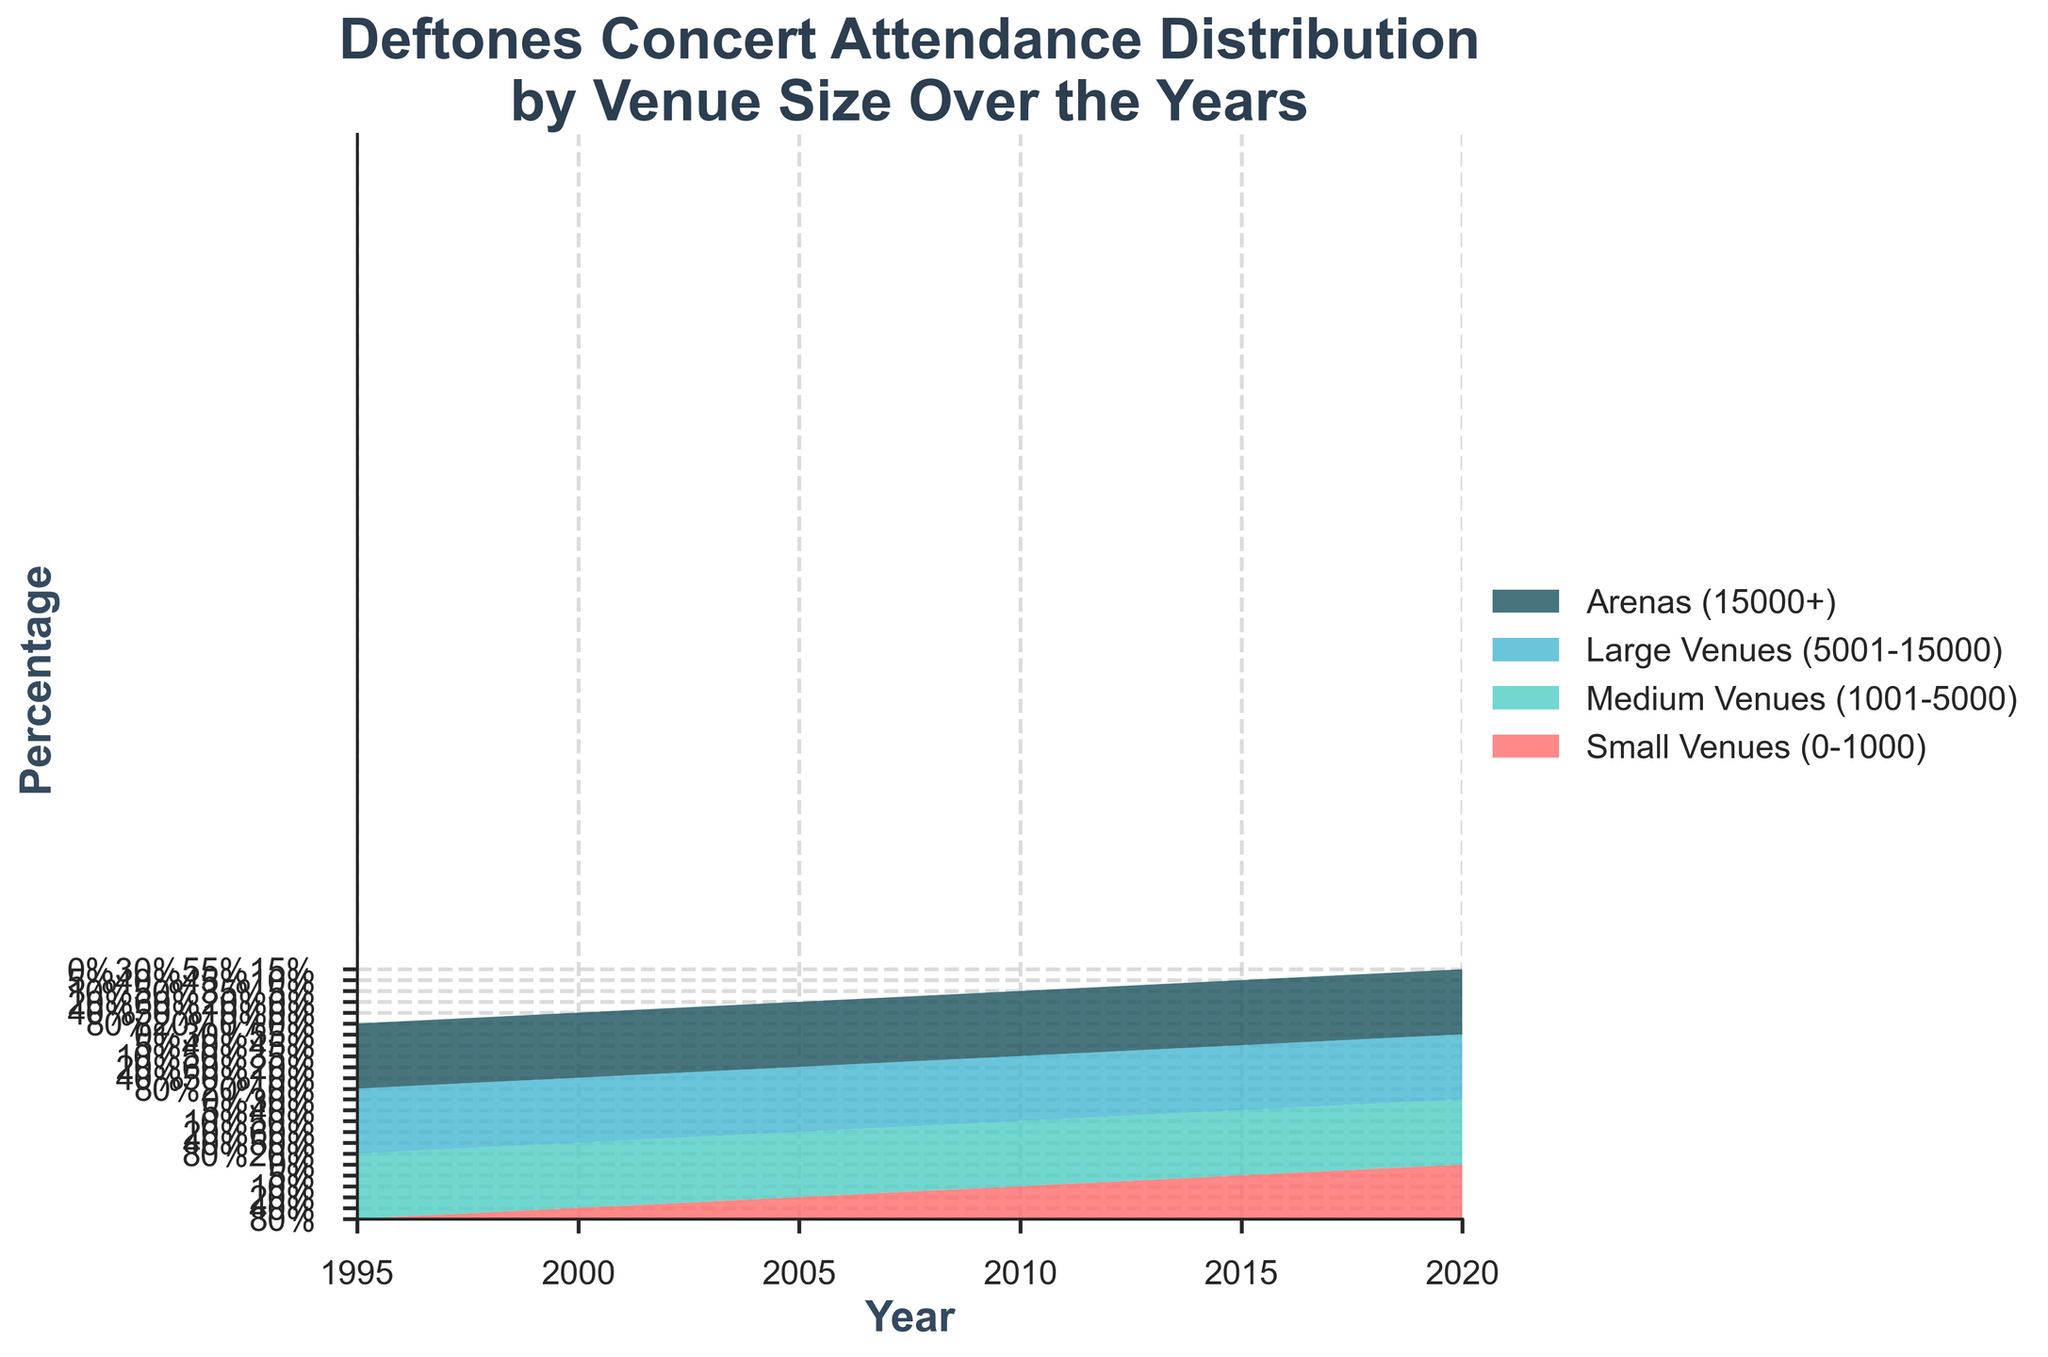what years are displayed on the x-axis? The x-axis of the graph displays the years when Deftones' concert attendance is documented. These years are read directly from the labels on the x-axis.
Answer: 1995, 2000, 2005, 2010, 2015, 2020 what is the title of the chart? The title of the chart provides an overview of the data shown and helps to understand what is being analyzed. It is read directly from the top of the chart.
Answer: Deftones Concert Attendance Distribution by Venue Size Over the Years which venue size had the highest percentage in 2015? To determine the highest percentage in 2015, look for the segment with the greatest height in that year on the chart. The colors and labels indicate the venue sizes.
Answer: Large Venues (5001-15000) how did the attendance at small venues (0-1000) change from 1995 to 2020? To understand the change in attendance at small venues from 1995 to 2020, compare the percentage values for small venues in both years.
Answer: Decreased from 80% to 0% in which year did medium venues (1001-5000) have their highest percentage? To find the year when medium venues had the highest percentage, look at the chart and identify the tallest segment specifically colored for medium venues.
Answer: 2005 what was the combined percentage of large venues (5001-15000) and arenas (15000+) in 2010? Sum the percentages of large venues and arenas for the year 2010. Large venues have 35% and arenas have 5%, so 35% + 5%.
Answer: 40% compare the attendance distribution between small and large venues in 2000. which was larger? Look at the values on the chart for small (yellow) and large (green) venues in the year 2000.
Answer: Medium venues (50%) were larger than small venues (40%) which venue size had a consistent increase from 1995 to 2020? Identify the trend for each venue size from 1995 to 2020 and see which one consistently increases over the years.
Answer: Large Venues (5001-15000) what is the greatest attendance percentage drop for small venues (0-1000) observed in the chart? To find the greatest percentage drop for small venues, look at the changes over the years and compute the most significant difference. The largest decrease is from 1995 (80%) to 2000 (40%), a drop of 40%.
Answer: 40% what percentage of attendance at arenas (15000+) was recorded in the year 2020? The percentage for arenas in 2020 can be read directly from the chart at the particular segment colored for arenas.
Answer: 15% 